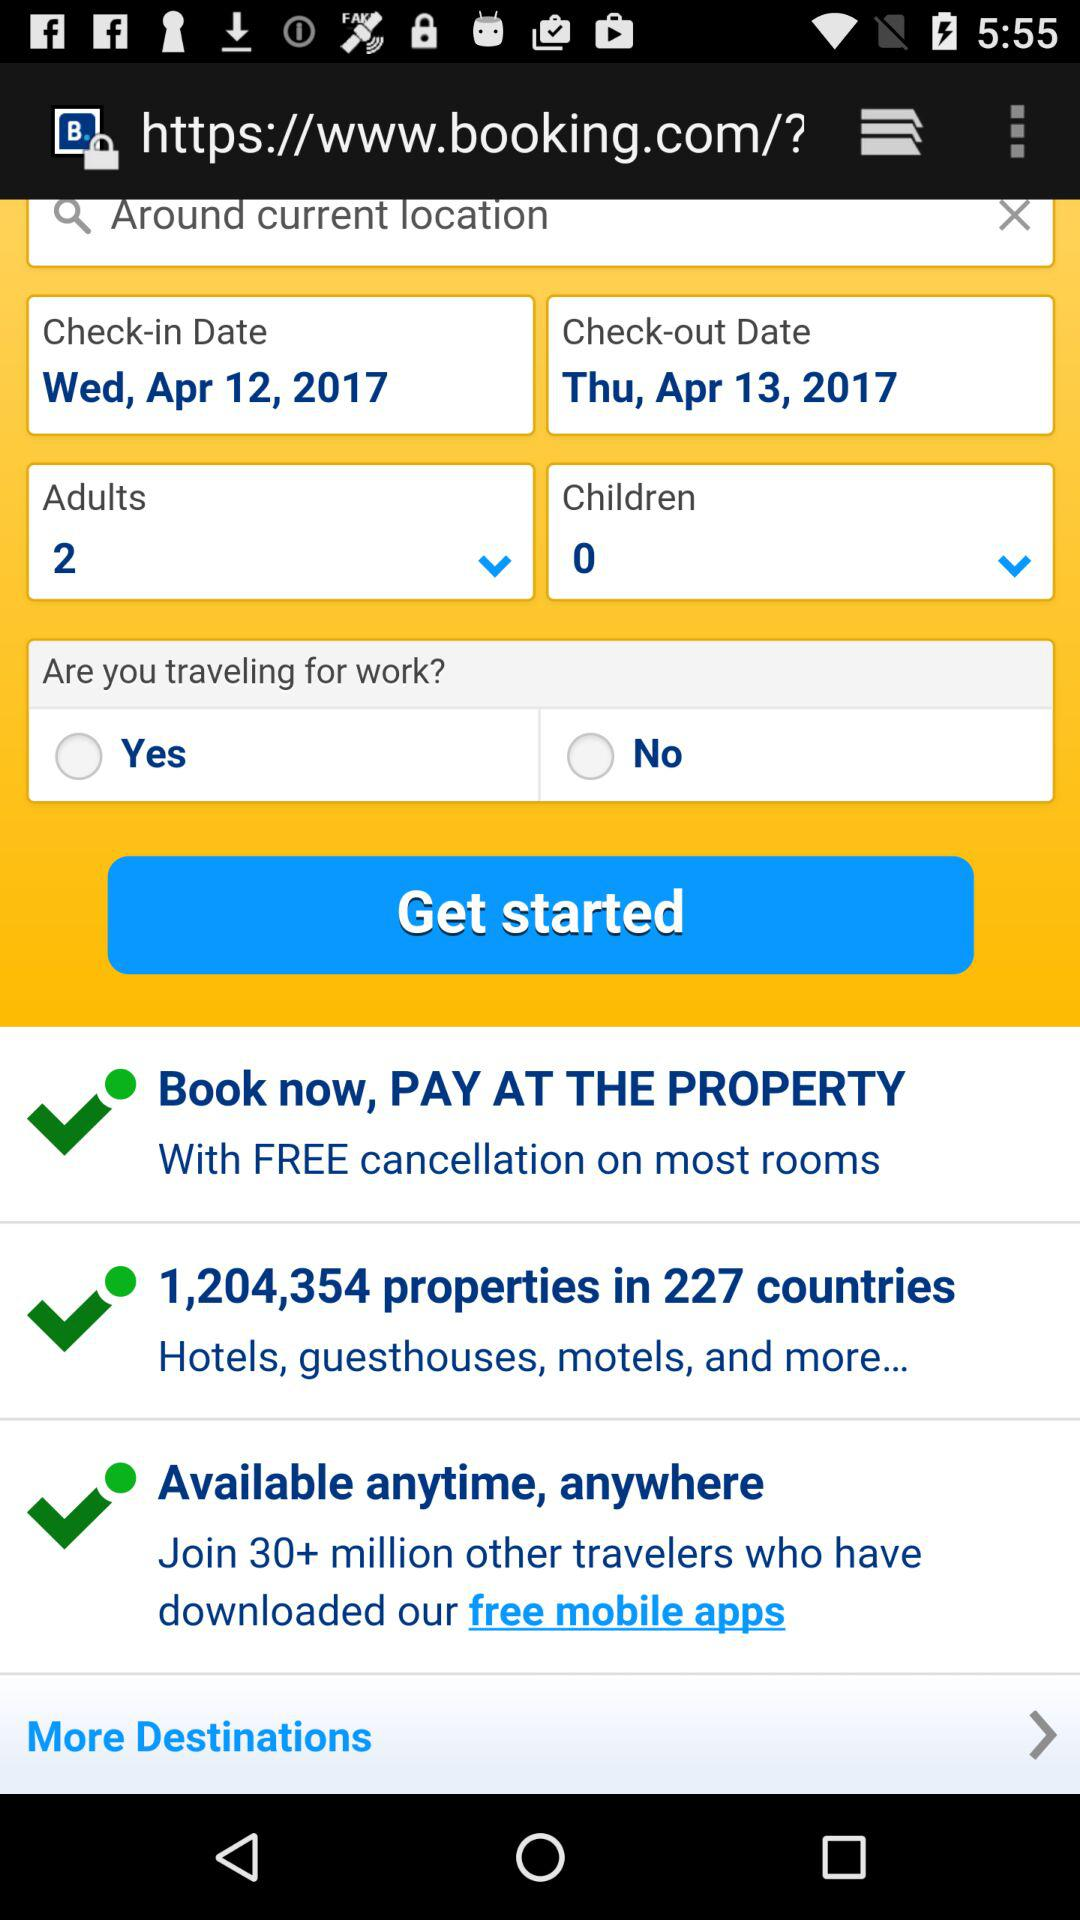What is the name of application?
When the provided information is insufficient, respond with <no answer>. <no answer> 